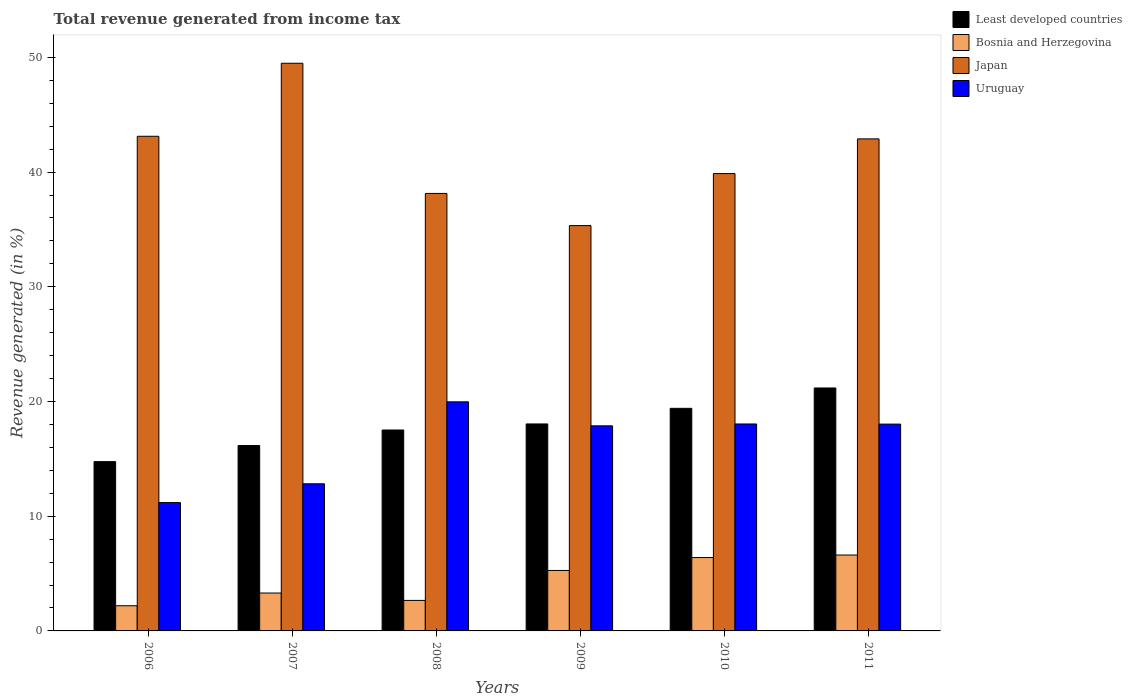How many different coloured bars are there?
Keep it short and to the point. 4. Are the number of bars per tick equal to the number of legend labels?
Ensure brevity in your answer.  Yes. How many bars are there on the 1st tick from the right?
Your answer should be compact. 4. What is the total revenue generated in Uruguay in 2010?
Make the answer very short. 18.04. Across all years, what is the maximum total revenue generated in Bosnia and Herzegovina?
Keep it short and to the point. 6.62. Across all years, what is the minimum total revenue generated in Least developed countries?
Your answer should be very brief. 14.76. In which year was the total revenue generated in Uruguay maximum?
Make the answer very short. 2008. What is the total total revenue generated in Least developed countries in the graph?
Ensure brevity in your answer.  107.07. What is the difference between the total revenue generated in Japan in 2006 and that in 2009?
Provide a succinct answer. 7.79. What is the difference between the total revenue generated in Bosnia and Herzegovina in 2011 and the total revenue generated in Least developed countries in 2006?
Give a very brief answer. -8.14. What is the average total revenue generated in Bosnia and Herzegovina per year?
Offer a terse response. 4.41. In the year 2006, what is the difference between the total revenue generated in Uruguay and total revenue generated in Bosnia and Herzegovina?
Provide a succinct answer. 8.99. In how many years, is the total revenue generated in Least developed countries greater than 22 %?
Your answer should be compact. 0. What is the ratio of the total revenue generated in Bosnia and Herzegovina in 2006 to that in 2011?
Give a very brief answer. 0.33. Is the total revenue generated in Japan in 2006 less than that in 2011?
Offer a terse response. No. Is the difference between the total revenue generated in Uruguay in 2008 and 2010 greater than the difference between the total revenue generated in Bosnia and Herzegovina in 2008 and 2010?
Provide a short and direct response. Yes. What is the difference between the highest and the second highest total revenue generated in Uruguay?
Give a very brief answer. 1.93. What is the difference between the highest and the lowest total revenue generated in Japan?
Make the answer very short. 14.15. In how many years, is the total revenue generated in Japan greater than the average total revenue generated in Japan taken over all years?
Ensure brevity in your answer.  3. What does the 4th bar from the left in 2010 represents?
Keep it short and to the point. Uruguay. What does the 4th bar from the right in 2009 represents?
Give a very brief answer. Least developed countries. Is it the case that in every year, the sum of the total revenue generated in Uruguay and total revenue generated in Least developed countries is greater than the total revenue generated in Bosnia and Herzegovina?
Offer a very short reply. Yes. How many bars are there?
Offer a very short reply. 24. Are all the bars in the graph horizontal?
Make the answer very short. No. Are the values on the major ticks of Y-axis written in scientific E-notation?
Offer a very short reply. No. Does the graph contain any zero values?
Your answer should be compact. No. Does the graph contain grids?
Provide a succinct answer. No. Where does the legend appear in the graph?
Your response must be concise. Top right. How are the legend labels stacked?
Offer a very short reply. Vertical. What is the title of the graph?
Your answer should be compact. Total revenue generated from income tax. Does "Sierra Leone" appear as one of the legend labels in the graph?
Offer a terse response. No. What is the label or title of the X-axis?
Make the answer very short. Years. What is the label or title of the Y-axis?
Provide a succinct answer. Revenue generated (in %). What is the Revenue generated (in %) in Least developed countries in 2006?
Offer a terse response. 14.76. What is the Revenue generated (in %) of Bosnia and Herzegovina in 2006?
Your answer should be compact. 2.19. What is the Revenue generated (in %) in Japan in 2006?
Keep it short and to the point. 43.12. What is the Revenue generated (in %) of Uruguay in 2006?
Keep it short and to the point. 11.19. What is the Revenue generated (in %) of Least developed countries in 2007?
Offer a very short reply. 16.16. What is the Revenue generated (in %) in Bosnia and Herzegovina in 2007?
Your answer should be compact. 3.3. What is the Revenue generated (in %) in Japan in 2007?
Ensure brevity in your answer.  49.49. What is the Revenue generated (in %) of Uruguay in 2007?
Provide a short and direct response. 12.83. What is the Revenue generated (in %) in Least developed countries in 2008?
Ensure brevity in your answer.  17.52. What is the Revenue generated (in %) in Bosnia and Herzegovina in 2008?
Ensure brevity in your answer.  2.66. What is the Revenue generated (in %) in Japan in 2008?
Give a very brief answer. 38.14. What is the Revenue generated (in %) in Uruguay in 2008?
Your response must be concise. 19.97. What is the Revenue generated (in %) of Least developed countries in 2009?
Provide a short and direct response. 18.04. What is the Revenue generated (in %) in Bosnia and Herzegovina in 2009?
Ensure brevity in your answer.  5.27. What is the Revenue generated (in %) of Japan in 2009?
Provide a short and direct response. 35.34. What is the Revenue generated (in %) of Uruguay in 2009?
Your answer should be very brief. 17.88. What is the Revenue generated (in %) of Least developed countries in 2010?
Give a very brief answer. 19.4. What is the Revenue generated (in %) of Bosnia and Herzegovina in 2010?
Ensure brevity in your answer.  6.4. What is the Revenue generated (in %) in Japan in 2010?
Keep it short and to the point. 39.87. What is the Revenue generated (in %) in Uruguay in 2010?
Ensure brevity in your answer.  18.04. What is the Revenue generated (in %) in Least developed countries in 2011?
Your answer should be compact. 21.18. What is the Revenue generated (in %) in Bosnia and Herzegovina in 2011?
Offer a very short reply. 6.62. What is the Revenue generated (in %) in Japan in 2011?
Give a very brief answer. 42.9. What is the Revenue generated (in %) in Uruguay in 2011?
Make the answer very short. 18.03. Across all years, what is the maximum Revenue generated (in %) of Least developed countries?
Make the answer very short. 21.18. Across all years, what is the maximum Revenue generated (in %) in Bosnia and Herzegovina?
Make the answer very short. 6.62. Across all years, what is the maximum Revenue generated (in %) in Japan?
Your answer should be very brief. 49.49. Across all years, what is the maximum Revenue generated (in %) in Uruguay?
Provide a succinct answer. 19.97. Across all years, what is the minimum Revenue generated (in %) of Least developed countries?
Give a very brief answer. 14.76. Across all years, what is the minimum Revenue generated (in %) of Bosnia and Herzegovina?
Your answer should be compact. 2.19. Across all years, what is the minimum Revenue generated (in %) in Japan?
Keep it short and to the point. 35.34. Across all years, what is the minimum Revenue generated (in %) of Uruguay?
Offer a terse response. 11.19. What is the total Revenue generated (in %) of Least developed countries in the graph?
Keep it short and to the point. 107.07. What is the total Revenue generated (in %) in Bosnia and Herzegovina in the graph?
Give a very brief answer. 26.44. What is the total Revenue generated (in %) in Japan in the graph?
Make the answer very short. 248.86. What is the total Revenue generated (in %) of Uruguay in the graph?
Provide a short and direct response. 97.94. What is the difference between the Revenue generated (in %) of Least developed countries in 2006 and that in 2007?
Provide a succinct answer. -1.4. What is the difference between the Revenue generated (in %) in Bosnia and Herzegovina in 2006 and that in 2007?
Provide a short and direct response. -1.11. What is the difference between the Revenue generated (in %) in Japan in 2006 and that in 2007?
Ensure brevity in your answer.  -6.37. What is the difference between the Revenue generated (in %) of Uruguay in 2006 and that in 2007?
Offer a very short reply. -1.64. What is the difference between the Revenue generated (in %) of Least developed countries in 2006 and that in 2008?
Your response must be concise. -2.76. What is the difference between the Revenue generated (in %) in Bosnia and Herzegovina in 2006 and that in 2008?
Offer a very short reply. -0.47. What is the difference between the Revenue generated (in %) of Japan in 2006 and that in 2008?
Provide a succinct answer. 4.98. What is the difference between the Revenue generated (in %) of Uruguay in 2006 and that in 2008?
Offer a very short reply. -8.78. What is the difference between the Revenue generated (in %) of Least developed countries in 2006 and that in 2009?
Offer a terse response. -3.29. What is the difference between the Revenue generated (in %) of Bosnia and Herzegovina in 2006 and that in 2009?
Make the answer very short. -3.08. What is the difference between the Revenue generated (in %) of Japan in 2006 and that in 2009?
Ensure brevity in your answer.  7.79. What is the difference between the Revenue generated (in %) of Uruguay in 2006 and that in 2009?
Your answer should be very brief. -6.69. What is the difference between the Revenue generated (in %) of Least developed countries in 2006 and that in 2010?
Offer a terse response. -4.65. What is the difference between the Revenue generated (in %) in Bosnia and Herzegovina in 2006 and that in 2010?
Make the answer very short. -4.2. What is the difference between the Revenue generated (in %) in Japan in 2006 and that in 2010?
Keep it short and to the point. 3.25. What is the difference between the Revenue generated (in %) of Uruguay in 2006 and that in 2010?
Provide a short and direct response. -6.85. What is the difference between the Revenue generated (in %) in Least developed countries in 2006 and that in 2011?
Offer a terse response. -6.42. What is the difference between the Revenue generated (in %) of Bosnia and Herzegovina in 2006 and that in 2011?
Give a very brief answer. -4.42. What is the difference between the Revenue generated (in %) of Japan in 2006 and that in 2011?
Ensure brevity in your answer.  0.23. What is the difference between the Revenue generated (in %) of Uruguay in 2006 and that in 2011?
Make the answer very short. -6.84. What is the difference between the Revenue generated (in %) of Least developed countries in 2007 and that in 2008?
Provide a succinct answer. -1.35. What is the difference between the Revenue generated (in %) in Bosnia and Herzegovina in 2007 and that in 2008?
Offer a very short reply. 0.64. What is the difference between the Revenue generated (in %) in Japan in 2007 and that in 2008?
Give a very brief answer. 11.35. What is the difference between the Revenue generated (in %) of Uruguay in 2007 and that in 2008?
Keep it short and to the point. -7.14. What is the difference between the Revenue generated (in %) in Least developed countries in 2007 and that in 2009?
Keep it short and to the point. -1.88. What is the difference between the Revenue generated (in %) in Bosnia and Herzegovina in 2007 and that in 2009?
Your answer should be compact. -1.97. What is the difference between the Revenue generated (in %) in Japan in 2007 and that in 2009?
Offer a very short reply. 14.15. What is the difference between the Revenue generated (in %) in Uruguay in 2007 and that in 2009?
Ensure brevity in your answer.  -5.05. What is the difference between the Revenue generated (in %) of Least developed countries in 2007 and that in 2010?
Provide a short and direct response. -3.24. What is the difference between the Revenue generated (in %) of Bosnia and Herzegovina in 2007 and that in 2010?
Make the answer very short. -3.09. What is the difference between the Revenue generated (in %) in Japan in 2007 and that in 2010?
Give a very brief answer. 9.62. What is the difference between the Revenue generated (in %) of Uruguay in 2007 and that in 2010?
Keep it short and to the point. -5.21. What is the difference between the Revenue generated (in %) in Least developed countries in 2007 and that in 2011?
Provide a short and direct response. -5.02. What is the difference between the Revenue generated (in %) of Bosnia and Herzegovina in 2007 and that in 2011?
Offer a terse response. -3.31. What is the difference between the Revenue generated (in %) in Japan in 2007 and that in 2011?
Your answer should be compact. 6.59. What is the difference between the Revenue generated (in %) in Uruguay in 2007 and that in 2011?
Give a very brief answer. -5.2. What is the difference between the Revenue generated (in %) of Least developed countries in 2008 and that in 2009?
Ensure brevity in your answer.  -0.53. What is the difference between the Revenue generated (in %) in Bosnia and Herzegovina in 2008 and that in 2009?
Ensure brevity in your answer.  -2.61. What is the difference between the Revenue generated (in %) in Japan in 2008 and that in 2009?
Provide a short and direct response. 2.8. What is the difference between the Revenue generated (in %) in Uruguay in 2008 and that in 2009?
Offer a very short reply. 2.09. What is the difference between the Revenue generated (in %) of Least developed countries in 2008 and that in 2010?
Your answer should be very brief. -1.89. What is the difference between the Revenue generated (in %) of Bosnia and Herzegovina in 2008 and that in 2010?
Provide a short and direct response. -3.74. What is the difference between the Revenue generated (in %) of Japan in 2008 and that in 2010?
Provide a succinct answer. -1.73. What is the difference between the Revenue generated (in %) in Uruguay in 2008 and that in 2010?
Offer a terse response. 1.93. What is the difference between the Revenue generated (in %) in Least developed countries in 2008 and that in 2011?
Ensure brevity in your answer.  -3.67. What is the difference between the Revenue generated (in %) of Bosnia and Herzegovina in 2008 and that in 2011?
Keep it short and to the point. -3.96. What is the difference between the Revenue generated (in %) in Japan in 2008 and that in 2011?
Your response must be concise. -4.76. What is the difference between the Revenue generated (in %) in Uruguay in 2008 and that in 2011?
Make the answer very short. 1.94. What is the difference between the Revenue generated (in %) of Least developed countries in 2009 and that in 2010?
Ensure brevity in your answer.  -1.36. What is the difference between the Revenue generated (in %) of Bosnia and Herzegovina in 2009 and that in 2010?
Keep it short and to the point. -1.13. What is the difference between the Revenue generated (in %) in Japan in 2009 and that in 2010?
Your answer should be very brief. -4.54. What is the difference between the Revenue generated (in %) in Uruguay in 2009 and that in 2010?
Keep it short and to the point. -0.16. What is the difference between the Revenue generated (in %) of Least developed countries in 2009 and that in 2011?
Your answer should be very brief. -3.14. What is the difference between the Revenue generated (in %) of Bosnia and Herzegovina in 2009 and that in 2011?
Provide a short and direct response. -1.35. What is the difference between the Revenue generated (in %) in Japan in 2009 and that in 2011?
Offer a terse response. -7.56. What is the difference between the Revenue generated (in %) in Uruguay in 2009 and that in 2011?
Make the answer very short. -0.15. What is the difference between the Revenue generated (in %) of Least developed countries in 2010 and that in 2011?
Provide a short and direct response. -1.78. What is the difference between the Revenue generated (in %) in Bosnia and Herzegovina in 2010 and that in 2011?
Offer a very short reply. -0.22. What is the difference between the Revenue generated (in %) of Japan in 2010 and that in 2011?
Make the answer very short. -3.02. What is the difference between the Revenue generated (in %) in Uruguay in 2010 and that in 2011?
Make the answer very short. 0.01. What is the difference between the Revenue generated (in %) of Least developed countries in 2006 and the Revenue generated (in %) of Bosnia and Herzegovina in 2007?
Your answer should be very brief. 11.45. What is the difference between the Revenue generated (in %) of Least developed countries in 2006 and the Revenue generated (in %) of Japan in 2007?
Provide a short and direct response. -34.73. What is the difference between the Revenue generated (in %) in Least developed countries in 2006 and the Revenue generated (in %) in Uruguay in 2007?
Your answer should be very brief. 1.93. What is the difference between the Revenue generated (in %) of Bosnia and Herzegovina in 2006 and the Revenue generated (in %) of Japan in 2007?
Your answer should be very brief. -47.3. What is the difference between the Revenue generated (in %) of Bosnia and Herzegovina in 2006 and the Revenue generated (in %) of Uruguay in 2007?
Ensure brevity in your answer.  -10.63. What is the difference between the Revenue generated (in %) of Japan in 2006 and the Revenue generated (in %) of Uruguay in 2007?
Offer a very short reply. 30.3. What is the difference between the Revenue generated (in %) of Least developed countries in 2006 and the Revenue generated (in %) of Bosnia and Herzegovina in 2008?
Provide a succinct answer. 12.1. What is the difference between the Revenue generated (in %) of Least developed countries in 2006 and the Revenue generated (in %) of Japan in 2008?
Offer a very short reply. -23.38. What is the difference between the Revenue generated (in %) in Least developed countries in 2006 and the Revenue generated (in %) in Uruguay in 2008?
Provide a succinct answer. -5.21. What is the difference between the Revenue generated (in %) of Bosnia and Herzegovina in 2006 and the Revenue generated (in %) of Japan in 2008?
Your answer should be compact. -35.95. What is the difference between the Revenue generated (in %) in Bosnia and Herzegovina in 2006 and the Revenue generated (in %) in Uruguay in 2008?
Provide a succinct answer. -17.78. What is the difference between the Revenue generated (in %) in Japan in 2006 and the Revenue generated (in %) in Uruguay in 2008?
Give a very brief answer. 23.15. What is the difference between the Revenue generated (in %) in Least developed countries in 2006 and the Revenue generated (in %) in Bosnia and Herzegovina in 2009?
Your response must be concise. 9.49. What is the difference between the Revenue generated (in %) in Least developed countries in 2006 and the Revenue generated (in %) in Japan in 2009?
Offer a very short reply. -20.58. What is the difference between the Revenue generated (in %) in Least developed countries in 2006 and the Revenue generated (in %) in Uruguay in 2009?
Your response must be concise. -3.12. What is the difference between the Revenue generated (in %) in Bosnia and Herzegovina in 2006 and the Revenue generated (in %) in Japan in 2009?
Provide a succinct answer. -33.14. What is the difference between the Revenue generated (in %) in Bosnia and Herzegovina in 2006 and the Revenue generated (in %) in Uruguay in 2009?
Your answer should be compact. -15.68. What is the difference between the Revenue generated (in %) of Japan in 2006 and the Revenue generated (in %) of Uruguay in 2009?
Offer a very short reply. 25.25. What is the difference between the Revenue generated (in %) in Least developed countries in 2006 and the Revenue generated (in %) in Bosnia and Herzegovina in 2010?
Provide a short and direct response. 8.36. What is the difference between the Revenue generated (in %) of Least developed countries in 2006 and the Revenue generated (in %) of Japan in 2010?
Your answer should be very brief. -25.11. What is the difference between the Revenue generated (in %) of Least developed countries in 2006 and the Revenue generated (in %) of Uruguay in 2010?
Make the answer very short. -3.28. What is the difference between the Revenue generated (in %) in Bosnia and Herzegovina in 2006 and the Revenue generated (in %) in Japan in 2010?
Offer a terse response. -37.68. What is the difference between the Revenue generated (in %) of Bosnia and Herzegovina in 2006 and the Revenue generated (in %) of Uruguay in 2010?
Provide a succinct answer. -15.85. What is the difference between the Revenue generated (in %) of Japan in 2006 and the Revenue generated (in %) of Uruguay in 2010?
Your answer should be very brief. 25.08. What is the difference between the Revenue generated (in %) of Least developed countries in 2006 and the Revenue generated (in %) of Bosnia and Herzegovina in 2011?
Your answer should be very brief. 8.14. What is the difference between the Revenue generated (in %) of Least developed countries in 2006 and the Revenue generated (in %) of Japan in 2011?
Your answer should be compact. -28.14. What is the difference between the Revenue generated (in %) in Least developed countries in 2006 and the Revenue generated (in %) in Uruguay in 2011?
Offer a terse response. -3.27. What is the difference between the Revenue generated (in %) of Bosnia and Herzegovina in 2006 and the Revenue generated (in %) of Japan in 2011?
Make the answer very short. -40.7. What is the difference between the Revenue generated (in %) in Bosnia and Herzegovina in 2006 and the Revenue generated (in %) in Uruguay in 2011?
Your answer should be compact. -15.84. What is the difference between the Revenue generated (in %) of Japan in 2006 and the Revenue generated (in %) of Uruguay in 2011?
Your answer should be compact. 25.09. What is the difference between the Revenue generated (in %) in Least developed countries in 2007 and the Revenue generated (in %) in Bosnia and Herzegovina in 2008?
Provide a succinct answer. 13.5. What is the difference between the Revenue generated (in %) in Least developed countries in 2007 and the Revenue generated (in %) in Japan in 2008?
Your response must be concise. -21.98. What is the difference between the Revenue generated (in %) in Least developed countries in 2007 and the Revenue generated (in %) in Uruguay in 2008?
Provide a succinct answer. -3.81. What is the difference between the Revenue generated (in %) of Bosnia and Herzegovina in 2007 and the Revenue generated (in %) of Japan in 2008?
Provide a succinct answer. -34.84. What is the difference between the Revenue generated (in %) of Bosnia and Herzegovina in 2007 and the Revenue generated (in %) of Uruguay in 2008?
Ensure brevity in your answer.  -16.67. What is the difference between the Revenue generated (in %) of Japan in 2007 and the Revenue generated (in %) of Uruguay in 2008?
Ensure brevity in your answer.  29.52. What is the difference between the Revenue generated (in %) in Least developed countries in 2007 and the Revenue generated (in %) in Bosnia and Herzegovina in 2009?
Ensure brevity in your answer.  10.89. What is the difference between the Revenue generated (in %) in Least developed countries in 2007 and the Revenue generated (in %) in Japan in 2009?
Give a very brief answer. -19.17. What is the difference between the Revenue generated (in %) of Least developed countries in 2007 and the Revenue generated (in %) of Uruguay in 2009?
Give a very brief answer. -1.72. What is the difference between the Revenue generated (in %) in Bosnia and Herzegovina in 2007 and the Revenue generated (in %) in Japan in 2009?
Your response must be concise. -32.03. What is the difference between the Revenue generated (in %) of Bosnia and Herzegovina in 2007 and the Revenue generated (in %) of Uruguay in 2009?
Your answer should be compact. -14.58. What is the difference between the Revenue generated (in %) in Japan in 2007 and the Revenue generated (in %) in Uruguay in 2009?
Give a very brief answer. 31.61. What is the difference between the Revenue generated (in %) of Least developed countries in 2007 and the Revenue generated (in %) of Bosnia and Herzegovina in 2010?
Provide a succinct answer. 9.77. What is the difference between the Revenue generated (in %) of Least developed countries in 2007 and the Revenue generated (in %) of Japan in 2010?
Ensure brevity in your answer.  -23.71. What is the difference between the Revenue generated (in %) in Least developed countries in 2007 and the Revenue generated (in %) in Uruguay in 2010?
Your answer should be compact. -1.88. What is the difference between the Revenue generated (in %) of Bosnia and Herzegovina in 2007 and the Revenue generated (in %) of Japan in 2010?
Ensure brevity in your answer.  -36.57. What is the difference between the Revenue generated (in %) of Bosnia and Herzegovina in 2007 and the Revenue generated (in %) of Uruguay in 2010?
Offer a very short reply. -14.74. What is the difference between the Revenue generated (in %) in Japan in 2007 and the Revenue generated (in %) in Uruguay in 2010?
Your answer should be compact. 31.45. What is the difference between the Revenue generated (in %) of Least developed countries in 2007 and the Revenue generated (in %) of Bosnia and Herzegovina in 2011?
Keep it short and to the point. 9.55. What is the difference between the Revenue generated (in %) of Least developed countries in 2007 and the Revenue generated (in %) of Japan in 2011?
Keep it short and to the point. -26.73. What is the difference between the Revenue generated (in %) in Least developed countries in 2007 and the Revenue generated (in %) in Uruguay in 2011?
Make the answer very short. -1.87. What is the difference between the Revenue generated (in %) in Bosnia and Herzegovina in 2007 and the Revenue generated (in %) in Japan in 2011?
Provide a short and direct response. -39.59. What is the difference between the Revenue generated (in %) in Bosnia and Herzegovina in 2007 and the Revenue generated (in %) in Uruguay in 2011?
Keep it short and to the point. -14.73. What is the difference between the Revenue generated (in %) of Japan in 2007 and the Revenue generated (in %) of Uruguay in 2011?
Make the answer very short. 31.46. What is the difference between the Revenue generated (in %) of Least developed countries in 2008 and the Revenue generated (in %) of Bosnia and Herzegovina in 2009?
Offer a terse response. 12.24. What is the difference between the Revenue generated (in %) of Least developed countries in 2008 and the Revenue generated (in %) of Japan in 2009?
Your response must be concise. -17.82. What is the difference between the Revenue generated (in %) of Least developed countries in 2008 and the Revenue generated (in %) of Uruguay in 2009?
Keep it short and to the point. -0.36. What is the difference between the Revenue generated (in %) in Bosnia and Herzegovina in 2008 and the Revenue generated (in %) in Japan in 2009?
Your response must be concise. -32.68. What is the difference between the Revenue generated (in %) in Bosnia and Herzegovina in 2008 and the Revenue generated (in %) in Uruguay in 2009?
Offer a very short reply. -15.22. What is the difference between the Revenue generated (in %) of Japan in 2008 and the Revenue generated (in %) of Uruguay in 2009?
Your response must be concise. 20.26. What is the difference between the Revenue generated (in %) in Least developed countries in 2008 and the Revenue generated (in %) in Bosnia and Herzegovina in 2010?
Your answer should be very brief. 11.12. What is the difference between the Revenue generated (in %) of Least developed countries in 2008 and the Revenue generated (in %) of Japan in 2010?
Make the answer very short. -22.36. What is the difference between the Revenue generated (in %) of Least developed countries in 2008 and the Revenue generated (in %) of Uruguay in 2010?
Keep it short and to the point. -0.53. What is the difference between the Revenue generated (in %) of Bosnia and Herzegovina in 2008 and the Revenue generated (in %) of Japan in 2010?
Keep it short and to the point. -37.21. What is the difference between the Revenue generated (in %) of Bosnia and Herzegovina in 2008 and the Revenue generated (in %) of Uruguay in 2010?
Your answer should be very brief. -15.38. What is the difference between the Revenue generated (in %) of Japan in 2008 and the Revenue generated (in %) of Uruguay in 2010?
Provide a short and direct response. 20.1. What is the difference between the Revenue generated (in %) in Least developed countries in 2008 and the Revenue generated (in %) in Bosnia and Herzegovina in 2011?
Make the answer very short. 10.9. What is the difference between the Revenue generated (in %) of Least developed countries in 2008 and the Revenue generated (in %) of Japan in 2011?
Your answer should be very brief. -25.38. What is the difference between the Revenue generated (in %) of Least developed countries in 2008 and the Revenue generated (in %) of Uruguay in 2011?
Ensure brevity in your answer.  -0.52. What is the difference between the Revenue generated (in %) of Bosnia and Herzegovina in 2008 and the Revenue generated (in %) of Japan in 2011?
Your answer should be compact. -40.24. What is the difference between the Revenue generated (in %) of Bosnia and Herzegovina in 2008 and the Revenue generated (in %) of Uruguay in 2011?
Give a very brief answer. -15.37. What is the difference between the Revenue generated (in %) of Japan in 2008 and the Revenue generated (in %) of Uruguay in 2011?
Provide a short and direct response. 20.11. What is the difference between the Revenue generated (in %) in Least developed countries in 2009 and the Revenue generated (in %) in Bosnia and Herzegovina in 2010?
Make the answer very short. 11.65. What is the difference between the Revenue generated (in %) in Least developed countries in 2009 and the Revenue generated (in %) in Japan in 2010?
Provide a short and direct response. -21.83. What is the difference between the Revenue generated (in %) in Least developed countries in 2009 and the Revenue generated (in %) in Uruguay in 2010?
Offer a very short reply. 0. What is the difference between the Revenue generated (in %) in Bosnia and Herzegovina in 2009 and the Revenue generated (in %) in Japan in 2010?
Your answer should be very brief. -34.6. What is the difference between the Revenue generated (in %) of Bosnia and Herzegovina in 2009 and the Revenue generated (in %) of Uruguay in 2010?
Offer a terse response. -12.77. What is the difference between the Revenue generated (in %) of Japan in 2009 and the Revenue generated (in %) of Uruguay in 2010?
Your answer should be very brief. 17.29. What is the difference between the Revenue generated (in %) in Least developed countries in 2009 and the Revenue generated (in %) in Bosnia and Herzegovina in 2011?
Provide a short and direct response. 11.43. What is the difference between the Revenue generated (in %) of Least developed countries in 2009 and the Revenue generated (in %) of Japan in 2011?
Your response must be concise. -24.85. What is the difference between the Revenue generated (in %) in Least developed countries in 2009 and the Revenue generated (in %) in Uruguay in 2011?
Ensure brevity in your answer.  0.01. What is the difference between the Revenue generated (in %) of Bosnia and Herzegovina in 2009 and the Revenue generated (in %) of Japan in 2011?
Provide a short and direct response. -37.62. What is the difference between the Revenue generated (in %) in Bosnia and Herzegovina in 2009 and the Revenue generated (in %) in Uruguay in 2011?
Ensure brevity in your answer.  -12.76. What is the difference between the Revenue generated (in %) of Japan in 2009 and the Revenue generated (in %) of Uruguay in 2011?
Ensure brevity in your answer.  17.31. What is the difference between the Revenue generated (in %) in Least developed countries in 2010 and the Revenue generated (in %) in Bosnia and Herzegovina in 2011?
Ensure brevity in your answer.  12.79. What is the difference between the Revenue generated (in %) of Least developed countries in 2010 and the Revenue generated (in %) of Japan in 2011?
Your response must be concise. -23.49. What is the difference between the Revenue generated (in %) of Least developed countries in 2010 and the Revenue generated (in %) of Uruguay in 2011?
Keep it short and to the point. 1.37. What is the difference between the Revenue generated (in %) of Bosnia and Herzegovina in 2010 and the Revenue generated (in %) of Japan in 2011?
Give a very brief answer. -36.5. What is the difference between the Revenue generated (in %) of Bosnia and Herzegovina in 2010 and the Revenue generated (in %) of Uruguay in 2011?
Offer a very short reply. -11.63. What is the difference between the Revenue generated (in %) of Japan in 2010 and the Revenue generated (in %) of Uruguay in 2011?
Offer a terse response. 21.84. What is the average Revenue generated (in %) of Least developed countries per year?
Make the answer very short. 17.84. What is the average Revenue generated (in %) of Bosnia and Herzegovina per year?
Give a very brief answer. 4.41. What is the average Revenue generated (in %) of Japan per year?
Keep it short and to the point. 41.48. What is the average Revenue generated (in %) of Uruguay per year?
Your answer should be compact. 16.32. In the year 2006, what is the difference between the Revenue generated (in %) in Least developed countries and Revenue generated (in %) in Bosnia and Herzegovina?
Your response must be concise. 12.56. In the year 2006, what is the difference between the Revenue generated (in %) of Least developed countries and Revenue generated (in %) of Japan?
Ensure brevity in your answer.  -28.37. In the year 2006, what is the difference between the Revenue generated (in %) in Least developed countries and Revenue generated (in %) in Uruguay?
Give a very brief answer. 3.57. In the year 2006, what is the difference between the Revenue generated (in %) in Bosnia and Herzegovina and Revenue generated (in %) in Japan?
Offer a terse response. -40.93. In the year 2006, what is the difference between the Revenue generated (in %) of Bosnia and Herzegovina and Revenue generated (in %) of Uruguay?
Offer a terse response. -8.99. In the year 2006, what is the difference between the Revenue generated (in %) in Japan and Revenue generated (in %) in Uruguay?
Provide a succinct answer. 31.94. In the year 2007, what is the difference between the Revenue generated (in %) in Least developed countries and Revenue generated (in %) in Bosnia and Herzegovina?
Offer a very short reply. 12.86. In the year 2007, what is the difference between the Revenue generated (in %) in Least developed countries and Revenue generated (in %) in Japan?
Ensure brevity in your answer.  -33.33. In the year 2007, what is the difference between the Revenue generated (in %) in Least developed countries and Revenue generated (in %) in Uruguay?
Ensure brevity in your answer.  3.34. In the year 2007, what is the difference between the Revenue generated (in %) of Bosnia and Herzegovina and Revenue generated (in %) of Japan?
Keep it short and to the point. -46.19. In the year 2007, what is the difference between the Revenue generated (in %) of Bosnia and Herzegovina and Revenue generated (in %) of Uruguay?
Your answer should be very brief. -9.52. In the year 2007, what is the difference between the Revenue generated (in %) of Japan and Revenue generated (in %) of Uruguay?
Give a very brief answer. 36.66. In the year 2008, what is the difference between the Revenue generated (in %) in Least developed countries and Revenue generated (in %) in Bosnia and Herzegovina?
Provide a succinct answer. 14.86. In the year 2008, what is the difference between the Revenue generated (in %) of Least developed countries and Revenue generated (in %) of Japan?
Provide a succinct answer. -20.62. In the year 2008, what is the difference between the Revenue generated (in %) in Least developed countries and Revenue generated (in %) in Uruguay?
Provide a short and direct response. -2.46. In the year 2008, what is the difference between the Revenue generated (in %) in Bosnia and Herzegovina and Revenue generated (in %) in Japan?
Your answer should be very brief. -35.48. In the year 2008, what is the difference between the Revenue generated (in %) of Bosnia and Herzegovina and Revenue generated (in %) of Uruguay?
Make the answer very short. -17.31. In the year 2008, what is the difference between the Revenue generated (in %) of Japan and Revenue generated (in %) of Uruguay?
Offer a terse response. 18.17. In the year 2009, what is the difference between the Revenue generated (in %) of Least developed countries and Revenue generated (in %) of Bosnia and Herzegovina?
Your response must be concise. 12.77. In the year 2009, what is the difference between the Revenue generated (in %) of Least developed countries and Revenue generated (in %) of Japan?
Provide a succinct answer. -17.29. In the year 2009, what is the difference between the Revenue generated (in %) of Least developed countries and Revenue generated (in %) of Uruguay?
Your answer should be very brief. 0.17. In the year 2009, what is the difference between the Revenue generated (in %) of Bosnia and Herzegovina and Revenue generated (in %) of Japan?
Give a very brief answer. -30.06. In the year 2009, what is the difference between the Revenue generated (in %) in Bosnia and Herzegovina and Revenue generated (in %) in Uruguay?
Give a very brief answer. -12.61. In the year 2009, what is the difference between the Revenue generated (in %) in Japan and Revenue generated (in %) in Uruguay?
Provide a succinct answer. 17.46. In the year 2010, what is the difference between the Revenue generated (in %) in Least developed countries and Revenue generated (in %) in Bosnia and Herzegovina?
Your answer should be compact. 13.01. In the year 2010, what is the difference between the Revenue generated (in %) in Least developed countries and Revenue generated (in %) in Japan?
Offer a very short reply. -20.47. In the year 2010, what is the difference between the Revenue generated (in %) in Least developed countries and Revenue generated (in %) in Uruguay?
Offer a terse response. 1.36. In the year 2010, what is the difference between the Revenue generated (in %) of Bosnia and Herzegovina and Revenue generated (in %) of Japan?
Your answer should be compact. -33.48. In the year 2010, what is the difference between the Revenue generated (in %) of Bosnia and Herzegovina and Revenue generated (in %) of Uruguay?
Keep it short and to the point. -11.64. In the year 2010, what is the difference between the Revenue generated (in %) of Japan and Revenue generated (in %) of Uruguay?
Your answer should be very brief. 21.83. In the year 2011, what is the difference between the Revenue generated (in %) of Least developed countries and Revenue generated (in %) of Bosnia and Herzegovina?
Your response must be concise. 14.56. In the year 2011, what is the difference between the Revenue generated (in %) of Least developed countries and Revenue generated (in %) of Japan?
Provide a short and direct response. -21.72. In the year 2011, what is the difference between the Revenue generated (in %) of Least developed countries and Revenue generated (in %) of Uruguay?
Your answer should be very brief. 3.15. In the year 2011, what is the difference between the Revenue generated (in %) in Bosnia and Herzegovina and Revenue generated (in %) in Japan?
Provide a short and direct response. -36.28. In the year 2011, what is the difference between the Revenue generated (in %) of Bosnia and Herzegovina and Revenue generated (in %) of Uruguay?
Your response must be concise. -11.41. In the year 2011, what is the difference between the Revenue generated (in %) of Japan and Revenue generated (in %) of Uruguay?
Offer a very short reply. 24.87. What is the ratio of the Revenue generated (in %) in Least developed countries in 2006 to that in 2007?
Give a very brief answer. 0.91. What is the ratio of the Revenue generated (in %) of Bosnia and Herzegovina in 2006 to that in 2007?
Offer a terse response. 0.66. What is the ratio of the Revenue generated (in %) in Japan in 2006 to that in 2007?
Offer a terse response. 0.87. What is the ratio of the Revenue generated (in %) in Uruguay in 2006 to that in 2007?
Make the answer very short. 0.87. What is the ratio of the Revenue generated (in %) in Least developed countries in 2006 to that in 2008?
Your response must be concise. 0.84. What is the ratio of the Revenue generated (in %) in Bosnia and Herzegovina in 2006 to that in 2008?
Ensure brevity in your answer.  0.82. What is the ratio of the Revenue generated (in %) of Japan in 2006 to that in 2008?
Make the answer very short. 1.13. What is the ratio of the Revenue generated (in %) of Uruguay in 2006 to that in 2008?
Offer a terse response. 0.56. What is the ratio of the Revenue generated (in %) in Least developed countries in 2006 to that in 2009?
Give a very brief answer. 0.82. What is the ratio of the Revenue generated (in %) of Bosnia and Herzegovina in 2006 to that in 2009?
Give a very brief answer. 0.42. What is the ratio of the Revenue generated (in %) in Japan in 2006 to that in 2009?
Offer a terse response. 1.22. What is the ratio of the Revenue generated (in %) in Uruguay in 2006 to that in 2009?
Offer a very short reply. 0.63. What is the ratio of the Revenue generated (in %) in Least developed countries in 2006 to that in 2010?
Your answer should be compact. 0.76. What is the ratio of the Revenue generated (in %) in Bosnia and Herzegovina in 2006 to that in 2010?
Provide a short and direct response. 0.34. What is the ratio of the Revenue generated (in %) of Japan in 2006 to that in 2010?
Your response must be concise. 1.08. What is the ratio of the Revenue generated (in %) in Uruguay in 2006 to that in 2010?
Provide a short and direct response. 0.62. What is the ratio of the Revenue generated (in %) of Least developed countries in 2006 to that in 2011?
Offer a terse response. 0.7. What is the ratio of the Revenue generated (in %) of Bosnia and Herzegovina in 2006 to that in 2011?
Keep it short and to the point. 0.33. What is the ratio of the Revenue generated (in %) in Uruguay in 2006 to that in 2011?
Offer a very short reply. 0.62. What is the ratio of the Revenue generated (in %) in Least developed countries in 2007 to that in 2008?
Provide a succinct answer. 0.92. What is the ratio of the Revenue generated (in %) of Bosnia and Herzegovina in 2007 to that in 2008?
Provide a succinct answer. 1.24. What is the ratio of the Revenue generated (in %) in Japan in 2007 to that in 2008?
Keep it short and to the point. 1.3. What is the ratio of the Revenue generated (in %) in Uruguay in 2007 to that in 2008?
Your response must be concise. 0.64. What is the ratio of the Revenue generated (in %) in Least developed countries in 2007 to that in 2009?
Provide a succinct answer. 0.9. What is the ratio of the Revenue generated (in %) in Bosnia and Herzegovina in 2007 to that in 2009?
Give a very brief answer. 0.63. What is the ratio of the Revenue generated (in %) in Japan in 2007 to that in 2009?
Offer a very short reply. 1.4. What is the ratio of the Revenue generated (in %) in Uruguay in 2007 to that in 2009?
Offer a very short reply. 0.72. What is the ratio of the Revenue generated (in %) in Least developed countries in 2007 to that in 2010?
Provide a succinct answer. 0.83. What is the ratio of the Revenue generated (in %) in Bosnia and Herzegovina in 2007 to that in 2010?
Your response must be concise. 0.52. What is the ratio of the Revenue generated (in %) in Japan in 2007 to that in 2010?
Make the answer very short. 1.24. What is the ratio of the Revenue generated (in %) in Uruguay in 2007 to that in 2010?
Your answer should be compact. 0.71. What is the ratio of the Revenue generated (in %) of Least developed countries in 2007 to that in 2011?
Make the answer very short. 0.76. What is the ratio of the Revenue generated (in %) of Bosnia and Herzegovina in 2007 to that in 2011?
Give a very brief answer. 0.5. What is the ratio of the Revenue generated (in %) of Japan in 2007 to that in 2011?
Keep it short and to the point. 1.15. What is the ratio of the Revenue generated (in %) in Uruguay in 2007 to that in 2011?
Give a very brief answer. 0.71. What is the ratio of the Revenue generated (in %) in Least developed countries in 2008 to that in 2009?
Ensure brevity in your answer.  0.97. What is the ratio of the Revenue generated (in %) in Bosnia and Herzegovina in 2008 to that in 2009?
Offer a very short reply. 0.5. What is the ratio of the Revenue generated (in %) of Japan in 2008 to that in 2009?
Offer a very short reply. 1.08. What is the ratio of the Revenue generated (in %) of Uruguay in 2008 to that in 2009?
Ensure brevity in your answer.  1.12. What is the ratio of the Revenue generated (in %) in Least developed countries in 2008 to that in 2010?
Make the answer very short. 0.9. What is the ratio of the Revenue generated (in %) in Bosnia and Herzegovina in 2008 to that in 2010?
Ensure brevity in your answer.  0.42. What is the ratio of the Revenue generated (in %) in Japan in 2008 to that in 2010?
Your response must be concise. 0.96. What is the ratio of the Revenue generated (in %) in Uruguay in 2008 to that in 2010?
Give a very brief answer. 1.11. What is the ratio of the Revenue generated (in %) of Least developed countries in 2008 to that in 2011?
Ensure brevity in your answer.  0.83. What is the ratio of the Revenue generated (in %) in Bosnia and Herzegovina in 2008 to that in 2011?
Provide a succinct answer. 0.4. What is the ratio of the Revenue generated (in %) of Japan in 2008 to that in 2011?
Make the answer very short. 0.89. What is the ratio of the Revenue generated (in %) in Uruguay in 2008 to that in 2011?
Give a very brief answer. 1.11. What is the ratio of the Revenue generated (in %) in Least developed countries in 2009 to that in 2010?
Offer a terse response. 0.93. What is the ratio of the Revenue generated (in %) of Bosnia and Herzegovina in 2009 to that in 2010?
Provide a short and direct response. 0.82. What is the ratio of the Revenue generated (in %) of Japan in 2009 to that in 2010?
Provide a short and direct response. 0.89. What is the ratio of the Revenue generated (in %) of Least developed countries in 2009 to that in 2011?
Offer a terse response. 0.85. What is the ratio of the Revenue generated (in %) of Bosnia and Herzegovina in 2009 to that in 2011?
Your answer should be very brief. 0.8. What is the ratio of the Revenue generated (in %) in Japan in 2009 to that in 2011?
Make the answer very short. 0.82. What is the ratio of the Revenue generated (in %) in Uruguay in 2009 to that in 2011?
Provide a short and direct response. 0.99. What is the ratio of the Revenue generated (in %) of Least developed countries in 2010 to that in 2011?
Offer a very short reply. 0.92. What is the ratio of the Revenue generated (in %) in Bosnia and Herzegovina in 2010 to that in 2011?
Make the answer very short. 0.97. What is the ratio of the Revenue generated (in %) of Japan in 2010 to that in 2011?
Your response must be concise. 0.93. What is the ratio of the Revenue generated (in %) in Uruguay in 2010 to that in 2011?
Your answer should be very brief. 1. What is the difference between the highest and the second highest Revenue generated (in %) in Least developed countries?
Provide a short and direct response. 1.78. What is the difference between the highest and the second highest Revenue generated (in %) in Bosnia and Herzegovina?
Your answer should be compact. 0.22. What is the difference between the highest and the second highest Revenue generated (in %) of Japan?
Keep it short and to the point. 6.37. What is the difference between the highest and the second highest Revenue generated (in %) of Uruguay?
Offer a very short reply. 1.93. What is the difference between the highest and the lowest Revenue generated (in %) of Least developed countries?
Provide a succinct answer. 6.42. What is the difference between the highest and the lowest Revenue generated (in %) of Bosnia and Herzegovina?
Keep it short and to the point. 4.42. What is the difference between the highest and the lowest Revenue generated (in %) of Japan?
Provide a short and direct response. 14.15. What is the difference between the highest and the lowest Revenue generated (in %) in Uruguay?
Provide a succinct answer. 8.78. 